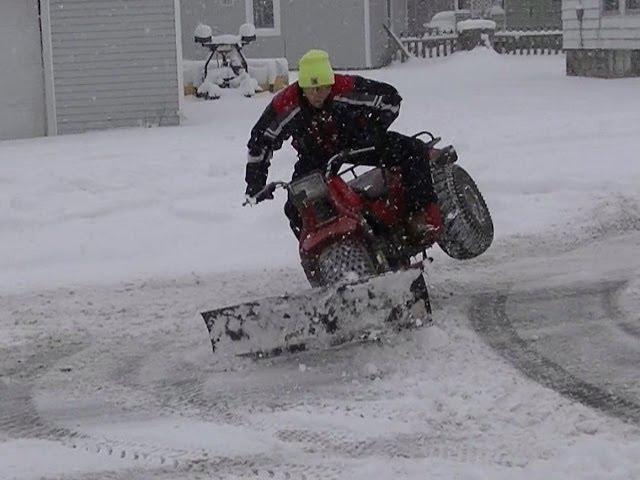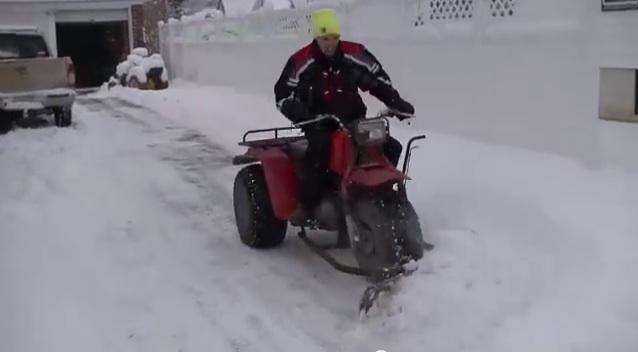The first image is the image on the left, the second image is the image on the right. Given the left and right images, does the statement "There is a human in each image." hold true? Answer yes or no. Yes. The first image is the image on the left, the second image is the image on the right. Analyze the images presented: Is the assertion "Each red three wheeler snowplow is being operated by a rider." valid? Answer yes or no. Yes. 